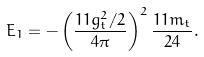<formula> <loc_0><loc_0><loc_500><loc_500>E _ { 1 } = - \left ( \frac { 1 1 g _ { t } ^ { 2 } / 2 } { 4 \pi } \right ) ^ { 2 } \frac { 1 1 m _ { t } } { 2 4 } .</formula> 